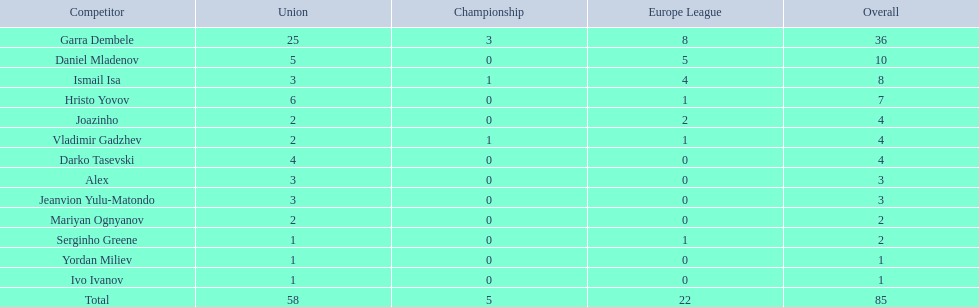Who are all of the players? Garra Dembele, Daniel Mladenov, Ismail Isa, Hristo Yovov, Joazinho, Vladimir Gadzhev, Darko Tasevski, Alex, Jeanvion Yulu-Matondo, Mariyan Ognyanov, Serginho Greene, Yordan Miliev, Ivo Ivanov. And which league is each player in? 25, 5, 3, 6, 2, 2, 4, 3, 3, 2, 1, 1, 1. Along with vladimir gadzhev and joazinho, which other player is in league 2? Mariyan Ognyanov. 